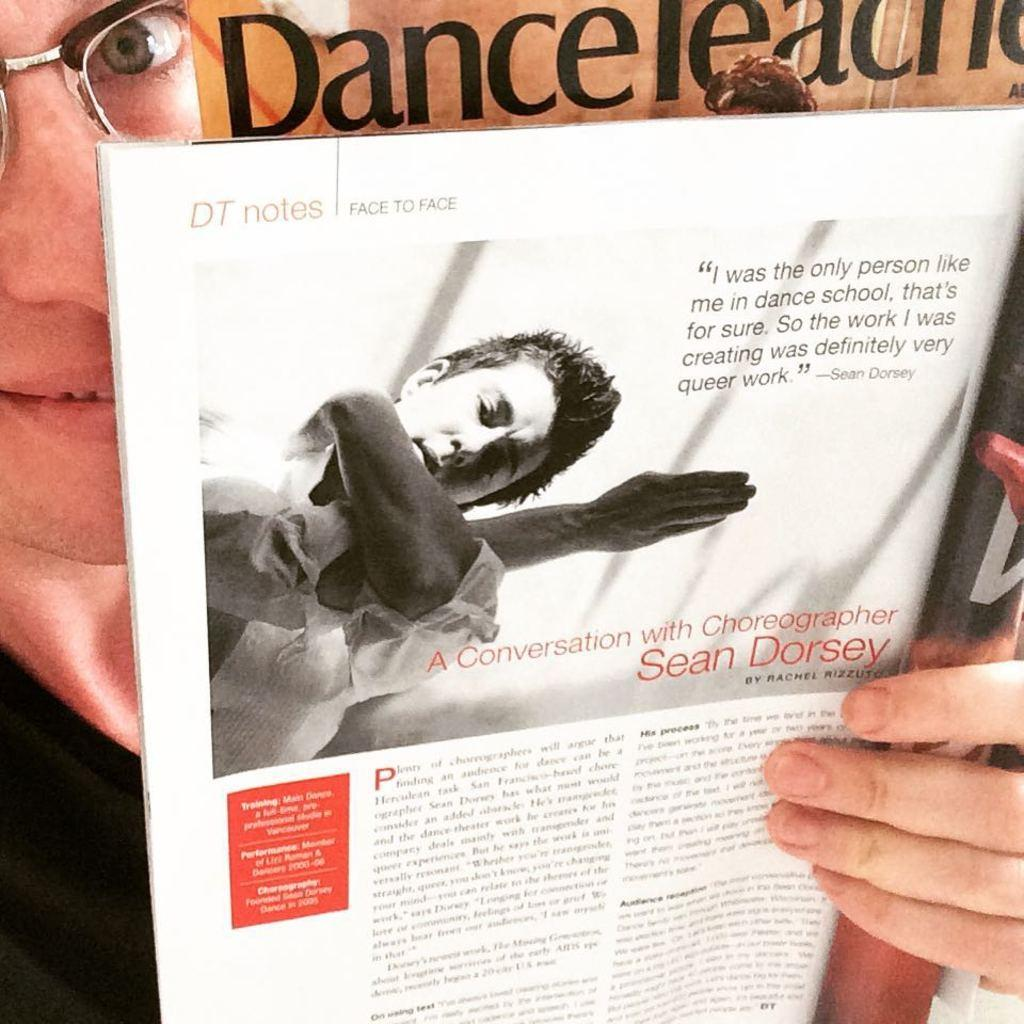Provide a one-sentence caption for the provided image. In this magazine you can read the article A Conversation with Choreographer Sean Dorsey. 